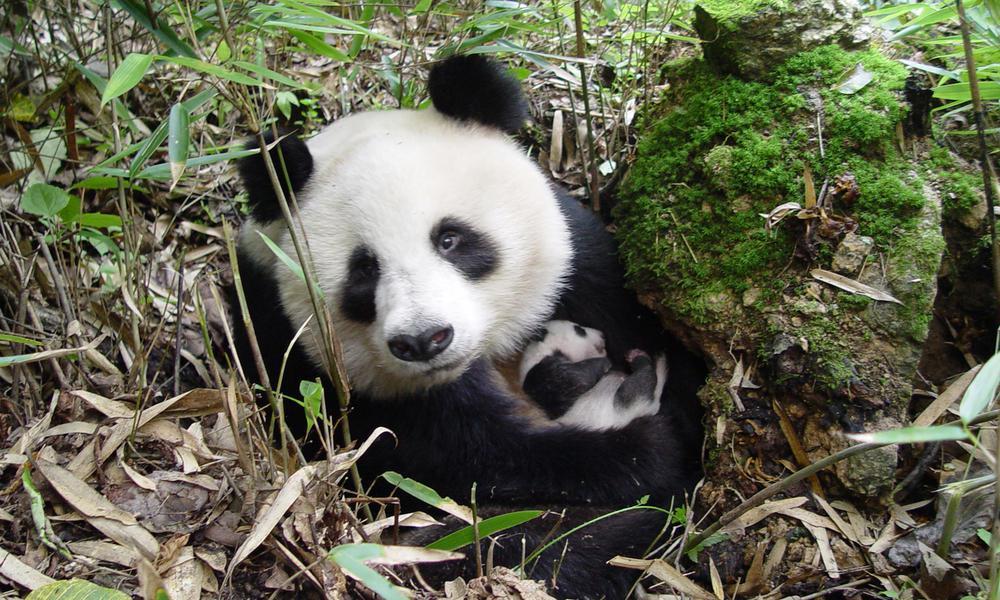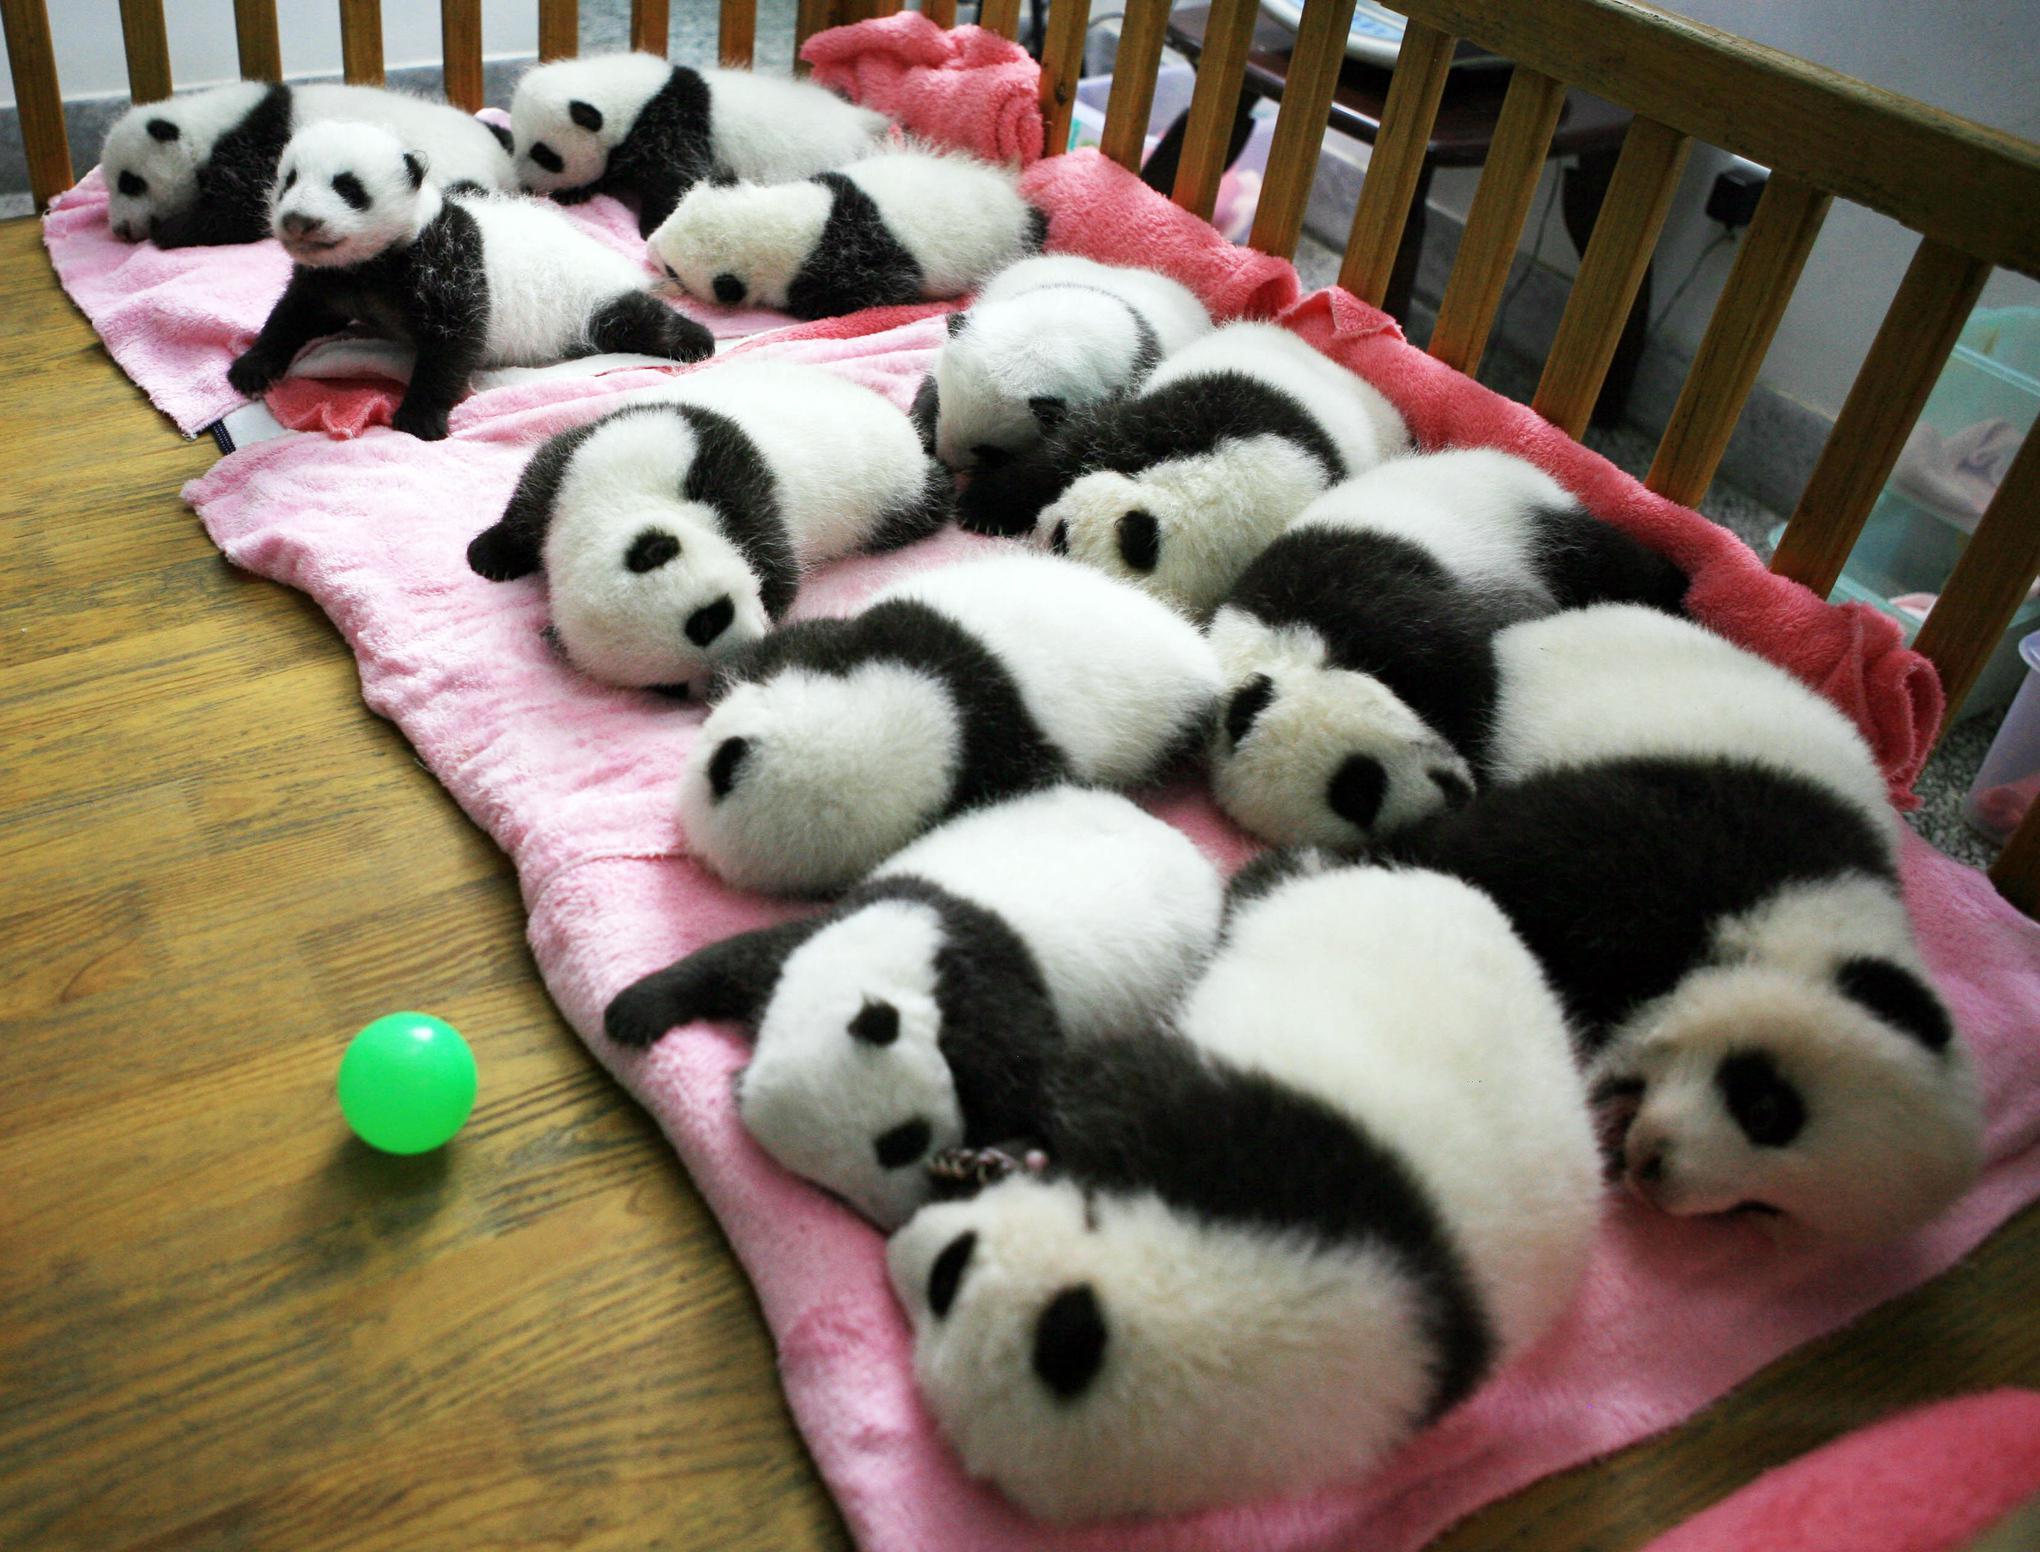The first image is the image on the left, the second image is the image on the right. For the images shown, is this caption "An image contains at lest four pandas." true? Answer yes or no. Yes. The first image is the image on the left, the second image is the image on the right. Given the left and right images, does the statement "The right image shows one panda, which is posed with open mouth to munch on a green stem." hold true? Answer yes or no. No. 